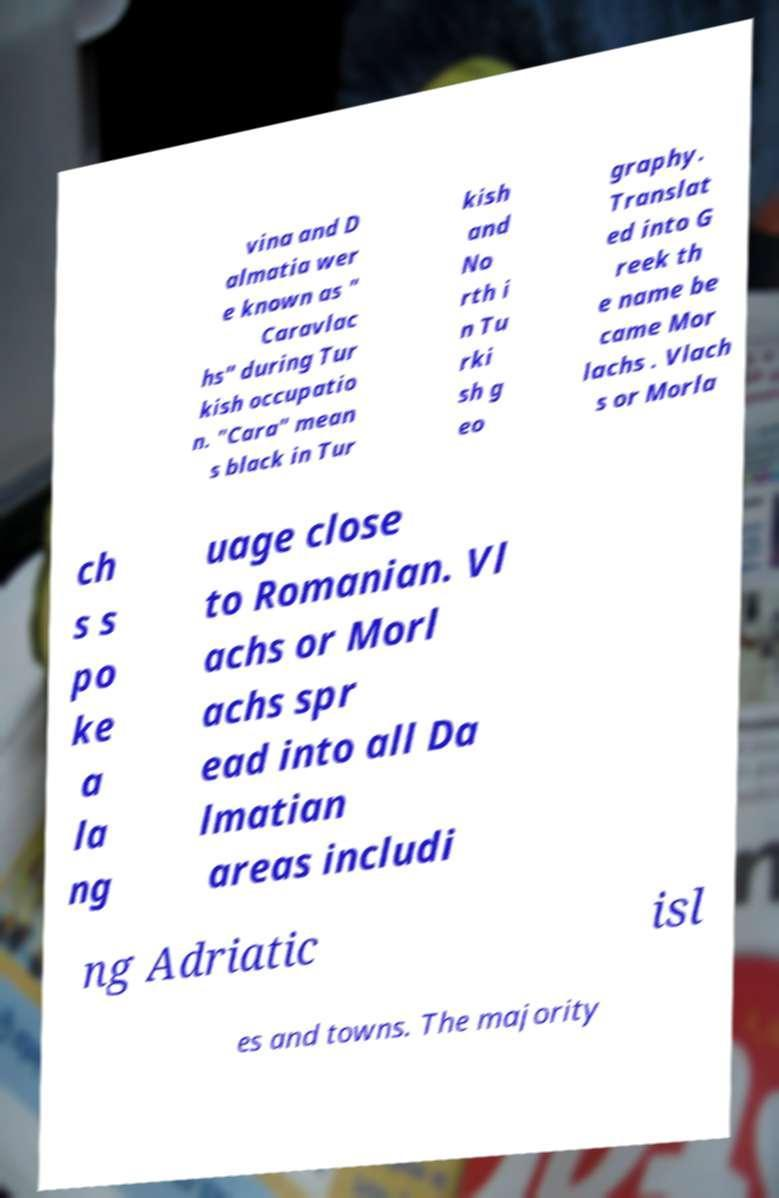For documentation purposes, I need the text within this image transcribed. Could you provide that? vina and D almatia wer e known as " Caravlac hs" during Tur kish occupatio n. "Cara" mean s black in Tur kish and No rth i n Tu rki sh g eo graphy. Translat ed into G reek th e name be came Mor lachs . Vlach s or Morla ch s s po ke a la ng uage close to Romanian. Vl achs or Morl achs spr ead into all Da lmatian areas includi ng Adriatic isl es and towns. The majority 